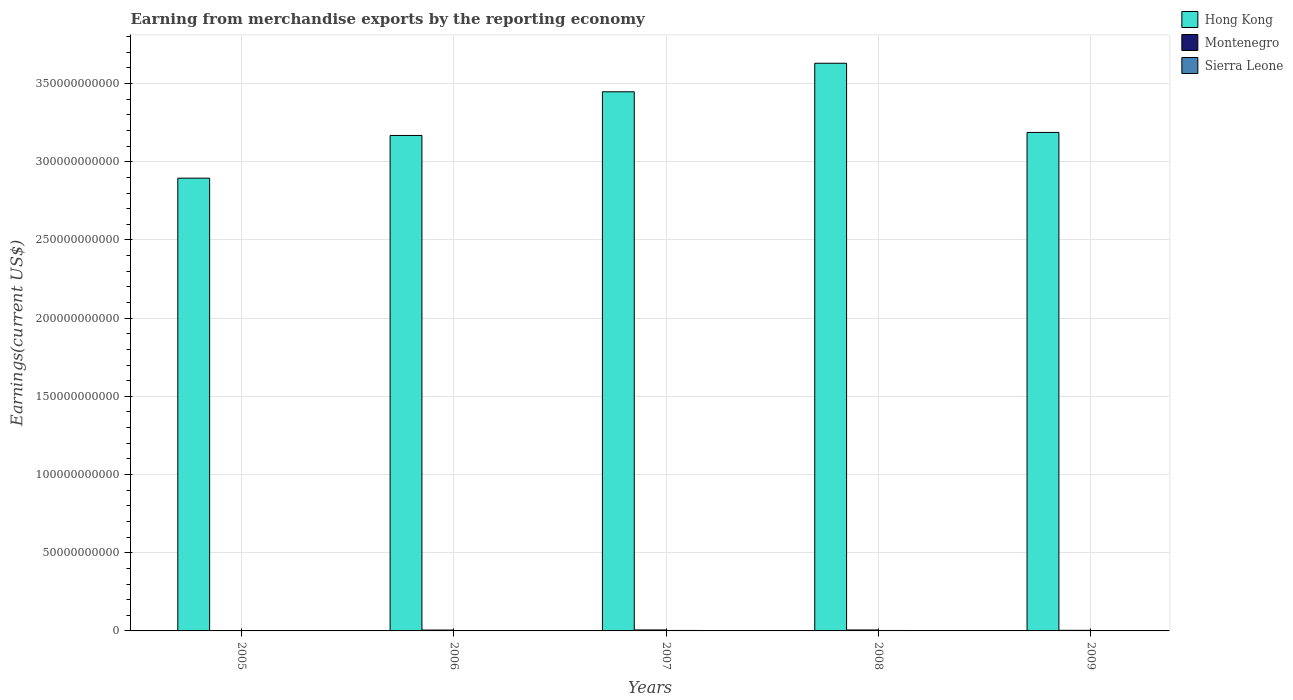Are the number of bars per tick equal to the number of legend labels?
Make the answer very short. Yes. How many bars are there on the 4th tick from the right?
Your response must be concise. 3. What is the label of the 5th group of bars from the left?
Your response must be concise. 2009. In how many cases, is the number of bars for a given year not equal to the number of legend labels?
Provide a succinct answer. 0. What is the amount earned from merchandise exports in Sierra Leone in 2009?
Keep it short and to the point. 2.15e+08. Across all years, what is the maximum amount earned from merchandise exports in Sierra Leone?
Keep it short and to the point. 3.05e+08. Across all years, what is the minimum amount earned from merchandise exports in Hong Kong?
Your answer should be very brief. 2.90e+11. In which year was the amount earned from merchandise exports in Sierra Leone minimum?
Your answer should be very brief. 2005. What is the total amount earned from merchandise exports in Sierra Leone in the graph?
Offer a very short reply. 1.20e+09. What is the difference between the amount earned from merchandise exports in Montenegro in 2008 and that in 2009?
Offer a very short reply. 2.23e+08. What is the difference between the amount earned from merchandise exports in Montenegro in 2007 and the amount earned from merchandise exports in Sierra Leone in 2009?
Provide a short and direct response. 4.06e+08. What is the average amount earned from merchandise exports in Hong Kong per year?
Ensure brevity in your answer.  3.27e+11. In the year 2005, what is the difference between the amount earned from merchandise exports in Sierra Leone and amount earned from merchandise exports in Montenegro?
Your answer should be compact. 1.04e+08. In how many years, is the amount earned from merchandise exports in Montenegro greater than 130000000000 US$?
Offer a very short reply. 0. What is the ratio of the amount earned from merchandise exports in Montenegro in 2006 to that in 2007?
Provide a succinct answer. 0.89. What is the difference between the highest and the second highest amount earned from merchandise exports in Montenegro?
Provide a succinct answer. 1.34e+07. What is the difference between the highest and the lowest amount earned from merchandise exports in Sierra Leone?
Ensure brevity in your answer.  1.09e+08. In how many years, is the amount earned from merchandise exports in Sierra Leone greater than the average amount earned from merchandise exports in Sierra Leone taken over all years?
Your response must be concise. 2. What does the 2nd bar from the left in 2005 represents?
Ensure brevity in your answer.  Montenegro. What does the 2nd bar from the right in 2008 represents?
Offer a very short reply. Montenegro. How many bars are there?
Make the answer very short. 15. Are the values on the major ticks of Y-axis written in scientific E-notation?
Provide a succinct answer. No. Where does the legend appear in the graph?
Ensure brevity in your answer.  Top right. How many legend labels are there?
Your response must be concise. 3. How are the legend labels stacked?
Offer a terse response. Vertical. What is the title of the graph?
Give a very brief answer. Earning from merchandise exports by the reporting economy. Does "Tunisia" appear as one of the legend labels in the graph?
Make the answer very short. No. What is the label or title of the X-axis?
Give a very brief answer. Years. What is the label or title of the Y-axis?
Offer a very short reply. Earnings(current US$). What is the Earnings(current US$) of Hong Kong in 2005?
Provide a succinct answer. 2.90e+11. What is the Earnings(current US$) in Montenegro in 2005?
Keep it short and to the point. 9.18e+07. What is the Earnings(current US$) in Sierra Leone in 2005?
Your answer should be compact. 1.96e+08. What is the Earnings(current US$) of Hong Kong in 2006?
Provide a succinct answer. 3.17e+11. What is the Earnings(current US$) of Montenegro in 2006?
Offer a very short reply. 5.53e+08. What is the Earnings(current US$) in Sierra Leone in 2006?
Your answer should be very brief. 2.08e+08. What is the Earnings(current US$) of Hong Kong in 2007?
Give a very brief answer. 3.45e+11. What is the Earnings(current US$) of Montenegro in 2007?
Your answer should be very brief. 6.20e+08. What is the Earnings(current US$) of Sierra Leone in 2007?
Make the answer very short. 3.05e+08. What is the Earnings(current US$) of Hong Kong in 2008?
Your answer should be compact. 3.63e+11. What is the Earnings(current US$) of Montenegro in 2008?
Make the answer very short. 6.07e+08. What is the Earnings(current US$) of Sierra Leone in 2008?
Your response must be concise. 2.73e+08. What is the Earnings(current US$) of Hong Kong in 2009?
Give a very brief answer. 3.19e+11. What is the Earnings(current US$) in Montenegro in 2009?
Make the answer very short. 3.84e+08. What is the Earnings(current US$) in Sierra Leone in 2009?
Offer a terse response. 2.15e+08. Across all years, what is the maximum Earnings(current US$) of Hong Kong?
Give a very brief answer. 3.63e+11. Across all years, what is the maximum Earnings(current US$) in Montenegro?
Keep it short and to the point. 6.20e+08. Across all years, what is the maximum Earnings(current US$) of Sierra Leone?
Your answer should be compact. 3.05e+08. Across all years, what is the minimum Earnings(current US$) in Hong Kong?
Your answer should be compact. 2.90e+11. Across all years, what is the minimum Earnings(current US$) of Montenegro?
Offer a very short reply. 9.18e+07. Across all years, what is the minimum Earnings(current US$) of Sierra Leone?
Your answer should be very brief. 1.96e+08. What is the total Earnings(current US$) of Hong Kong in the graph?
Give a very brief answer. 1.63e+12. What is the total Earnings(current US$) in Montenegro in the graph?
Provide a short and direct response. 2.26e+09. What is the total Earnings(current US$) in Sierra Leone in the graph?
Ensure brevity in your answer.  1.20e+09. What is the difference between the Earnings(current US$) of Hong Kong in 2005 and that in 2006?
Your answer should be very brief. -2.73e+1. What is the difference between the Earnings(current US$) of Montenegro in 2005 and that in 2006?
Your answer should be very brief. -4.62e+08. What is the difference between the Earnings(current US$) in Sierra Leone in 2005 and that in 2006?
Your response must be concise. -1.21e+07. What is the difference between the Earnings(current US$) in Hong Kong in 2005 and that in 2007?
Provide a succinct answer. -5.52e+1. What is the difference between the Earnings(current US$) in Montenegro in 2005 and that in 2007?
Provide a succinct answer. -5.29e+08. What is the difference between the Earnings(current US$) in Sierra Leone in 2005 and that in 2007?
Give a very brief answer. -1.09e+08. What is the difference between the Earnings(current US$) of Hong Kong in 2005 and that in 2008?
Ensure brevity in your answer.  -7.35e+1. What is the difference between the Earnings(current US$) in Montenegro in 2005 and that in 2008?
Provide a succinct answer. -5.15e+08. What is the difference between the Earnings(current US$) in Sierra Leone in 2005 and that in 2008?
Offer a very short reply. -7.68e+07. What is the difference between the Earnings(current US$) in Hong Kong in 2005 and that in 2009?
Offer a very short reply. -2.92e+1. What is the difference between the Earnings(current US$) in Montenegro in 2005 and that in 2009?
Offer a very short reply. -2.92e+08. What is the difference between the Earnings(current US$) of Sierra Leone in 2005 and that in 2009?
Your response must be concise. -1.86e+07. What is the difference between the Earnings(current US$) in Hong Kong in 2006 and that in 2007?
Ensure brevity in your answer.  -2.79e+1. What is the difference between the Earnings(current US$) in Montenegro in 2006 and that in 2007?
Your response must be concise. -6.70e+07. What is the difference between the Earnings(current US$) in Sierra Leone in 2006 and that in 2007?
Provide a short and direct response. -9.68e+07. What is the difference between the Earnings(current US$) of Hong Kong in 2006 and that in 2008?
Provide a succinct answer. -4.62e+1. What is the difference between the Earnings(current US$) in Montenegro in 2006 and that in 2008?
Ensure brevity in your answer.  -5.36e+07. What is the difference between the Earnings(current US$) in Sierra Leone in 2006 and that in 2008?
Provide a short and direct response. -6.46e+07. What is the difference between the Earnings(current US$) in Hong Kong in 2006 and that in 2009?
Provide a succinct answer. -1.93e+09. What is the difference between the Earnings(current US$) in Montenegro in 2006 and that in 2009?
Ensure brevity in your answer.  1.69e+08. What is the difference between the Earnings(current US$) of Sierra Leone in 2006 and that in 2009?
Offer a terse response. -6.45e+06. What is the difference between the Earnings(current US$) in Hong Kong in 2007 and that in 2008?
Provide a short and direct response. -1.82e+1. What is the difference between the Earnings(current US$) of Montenegro in 2007 and that in 2008?
Make the answer very short. 1.34e+07. What is the difference between the Earnings(current US$) in Sierra Leone in 2007 and that in 2008?
Offer a very short reply. 3.22e+07. What is the difference between the Earnings(current US$) of Hong Kong in 2007 and that in 2009?
Keep it short and to the point. 2.60e+1. What is the difference between the Earnings(current US$) in Montenegro in 2007 and that in 2009?
Provide a succinct answer. 2.36e+08. What is the difference between the Earnings(current US$) in Sierra Leone in 2007 and that in 2009?
Offer a very short reply. 9.04e+07. What is the difference between the Earnings(current US$) in Hong Kong in 2008 and that in 2009?
Give a very brief answer. 4.42e+1. What is the difference between the Earnings(current US$) in Montenegro in 2008 and that in 2009?
Provide a succinct answer. 2.23e+08. What is the difference between the Earnings(current US$) of Sierra Leone in 2008 and that in 2009?
Ensure brevity in your answer.  5.82e+07. What is the difference between the Earnings(current US$) in Hong Kong in 2005 and the Earnings(current US$) in Montenegro in 2006?
Offer a terse response. 2.89e+11. What is the difference between the Earnings(current US$) in Hong Kong in 2005 and the Earnings(current US$) in Sierra Leone in 2006?
Your response must be concise. 2.89e+11. What is the difference between the Earnings(current US$) in Montenegro in 2005 and the Earnings(current US$) in Sierra Leone in 2006?
Your answer should be compact. -1.16e+08. What is the difference between the Earnings(current US$) of Hong Kong in 2005 and the Earnings(current US$) of Montenegro in 2007?
Provide a succinct answer. 2.89e+11. What is the difference between the Earnings(current US$) of Hong Kong in 2005 and the Earnings(current US$) of Sierra Leone in 2007?
Your answer should be compact. 2.89e+11. What is the difference between the Earnings(current US$) in Montenegro in 2005 and the Earnings(current US$) in Sierra Leone in 2007?
Your answer should be very brief. -2.13e+08. What is the difference between the Earnings(current US$) in Hong Kong in 2005 and the Earnings(current US$) in Montenegro in 2008?
Your answer should be very brief. 2.89e+11. What is the difference between the Earnings(current US$) of Hong Kong in 2005 and the Earnings(current US$) of Sierra Leone in 2008?
Your answer should be very brief. 2.89e+11. What is the difference between the Earnings(current US$) of Montenegro in 2005 and the Earnings(current US$) of Sierra Leone in 2008?
Your response must be concise. -1.81e+08. What is the difference between the Earnings(current US$) in Hong Kong in 2005 and the Earnings(current US$) in Montenegro in 2009?
Provide a succinct answer. 2.89e+11. What is the difference between the Earnings(current US$) of Hong Kong in 2005 and the Earnings(current US$) of Sierra Leone in 2009?
Provide a short and direct response. 2.89e+11. What is the difference between the Earnings(current US$) in Montenegro in 2005 and the Earnings(current US$) in Sierra Leone in 2009?
Ensure brevity in your answer.  -1.23e+08. What is the difference between the Earnings(current US$) of Hong Kong in 2006 and the Earnings(current US$) of Montenegro in 2007?
Provide a succinct answer. 3.16e+11. What is the difference between the Earnings(current US$) of Hong Kong in 2006 and the Earnings(current US$) of Sierra Leone in 2007?
Give a very brief answer. 3.17e+11. What is the difference between the Earnings(current US$) of Montenegro in 2006 and the Earnings(current US$) of Sierra Leone in 2007?
Make the answer very short. 2.48e+08. What is the difference between the Earnings(current US$) in Hong Kong in 2006 and the Earnings(current US$) in Montenegro in 2008?
Your response must be concise. 3.16e+11. What is the difference between the Earnings(current US$) in Hong Kong in 2006 and the Earnings(current US$) in Sierra Leone in 2008?
Provide a succinct answer. 3.17e+11. What is the difference between the Earnings(current US$) of Montenegro in 2006 and the Earnings(current US$) of Sierra Leone in 2008?
Offer a very short reply. 2.81e+08. What is the difference between the Earnings(current US$) of Hong Kong in 2006 and the Earnings(current US$) of Montenegro in 2009?
Give a very brief answer. 3.16e+11. What is the difference between the Earnings(current US$) of Hong Kong in 2006 and the Earnings(current US$) of Sierra Leone in 2009?
Provide a succinct answer. 3.17e+11. What is the difference between the Earnings(current US$) of Montenegro in 2006 and the Earnings(current US$) of Sierra Leone in 2009?
Your answer should be very brief. 3.39e+08. What is the difference between the Earnings(current US$) of Hong Kong in 2007 and the Earnings(current US$) of Montenegro in 2008?
Make the answer very short. 3.44e+11. What is the difference between the Earnings(current US$) in Hong Kong in 2007 and the Earnings(current US$) in Sierra Leone in 2008?
Your answer should be compact. 3.44e+11. What is the difference between the Earnings(current US$) in Montenegro in 2007 and the Earnings(current US$) in Sierra Leone in 2008?
Offer a very short reply. 3.48e+08. What is the difference between the Earnings(current US$) in Hong Kong in 2007 and the Earnings(current US$) in Montenegro in 2009?
Make the answer very short. 3.44e+11. What is the difference between the Earnings(current US$) in Hong Kong in 2007 and the Earnings(current US$) in Sierra Leone in 2009?
Your response must be concise. 3.45e+11. What is the difference between the Earnings(current US$) in Montenegro in 2007 and the Earnings(current US$) in Sierra Leone in 2009?
Ensure brevity in your answer.  4.06e+08. What is the difference between the Earnings(current US$) in Hong Kong in 2008 and the Earnings(current US$) in Montenegro in 2009?
Offer a very short reply. 3.63e+11. What is the difference between the Earnings(current US$) in Hong Kong in 2008 and the Earnings(current US$) in Sierra Leone in 2009?
Your answer should be compact. 3.63e+11. What is the difference between the Earnings(current US$) in Montenegro in 2008 and the Earnings(current US$) in Sierra Leone in 2009?
Ensure brevity in your answer.  3.92e+08. What is the average Earnings(current US$) in Hong Kong per year?
Offer a very short reply. 3.27e+11. What is the average Earnings(current US$) of Montenegro per year?
Provide a succinct answer. 4.51e+08. What is the average Earnings(current US$) in Sierra Leone per year?
Give a very brief answer. 2.39e+08. In the year 2005, what is the difference between the Earnings(current US$) of Hong Kong and Earnings(current US$) of Montenegro?
Give a very brief answer. 2.89e+11. In the year 2005, what is the difference between the Earnings(current US$) of Hong Kong and Earnings(current US$) of Sierra Leone?
Offer a terse response. 2.89e+11. In the year 2005, what is the difference between the Earnings(current US$) in Montenegro and Earnings(current US$) in Sierra Leone?
Ensure brevity in your answer.  -1.04e+08. In the year 2006, what is the difference between the Earnings(current US$) of Hong Kong and Earnings(current US$) of Montenegro?
Your answer should be very brief. 3.16e+11. In the year 2006, what is the difference between the Earnings(current US$) in Hong Kong and Earnings(current US$) in Sierra Leone?
Provide a short and direct response. 3.17e+11. In the year 2006, what is the difference between the Earnings(current US$) in Montenegro and Earnings(current US$) in Sierra Leone?
Make the answer very short. 3.45e+08. In the year 2007, what is the difference between the Earnings(current US$) of Hong Kong and Earnings(current US$) of Montenegro?
Offer a terse response. 3.44e+11. In the year 2007, what is the difference between the Earnings(current US$) of Hong Kong and Earnings(current US$) of Sierra Leone?
Provide a succinct answer. 3.44e+11. In the year 2007, what is the difference between the Earnings(current US$) in Montenegro and Earnings(current US$) in Sierra Leone?
Keep it short and to the point. 3.15e+08. In the year 2008, what is the difference between the Earnings(current US$) of Hong Kong and Earnings(current US$) of Montenegro?
Offer a very short reply. 3.62e+11. In the year 2008, what is the difference between the Earnings(current US$) in Hong Kong and Earnings(current US$) in Sierra Leone?
Provide a short and direct response. 3.63e+11. In the year 2008, what is the difference between the Earnings(current US$) of Montenegro and Earnings(current US$) of Sierra Leone?
Your response must be concise. 3.34e+08. In the year 2009, what is the difference between the Earnings(current US$) in Hong Kong and Earnings(current US$) in Montenegro?
Offer a very short reply. 3.18e+11. In the year 2009, what is the difference between the Earnings(current US$) in Hong Kong and Earnings(current US$) in Sierra Leone?
Provide a short and direct response. 3.19e+11. In the year 2009, what is the difference between the Earnings(current US$) of Montenegro and Earnings(current US$) of Sierra Leone?
Give a very brief answer. 1.69e+08. What is the ratio of the Earnings(current US$) of Hong Kong in 2005 to that in 2006?
Your answer should be compact. 0.91. What is the ratio of the Earnings(current US$) of Montenegro in 2005 to that in 2006?
Provide a short and direct response. 0.17. What is the ratio of the Earnings(current US$) in Sierra Leone in 2005 to that in 2006?
Make the answer very short. 0.94. What is the ratio of the Earnings(current US$) in Hong Kong in 2005 to that in 2007?
Keep it short and to the point. 0.84. What is the ratio of the Earnings(current US$) in Montenegro in 2005 to that in 2007?
Make the answer very short. 0.15. What is the ratio of the Earnings(current US$) of Sierra Leone in 2005 to that in 2007?
Your response must be concise. 0.64. What is the ratio of the Earnings(current US$) of Hong Kong in 2005 to that in 2008?
Offer a terse response. 0.8. What is the ratio of the Earnings(current US$) in Montenegro in 2005 to that in 2008?
Your answer should be compact. 0.15. What is the ratio of the Earnings(current US$) in Sierra Leone in 2005 to that in 2008?
Ensure brevity in your answer.  0.72. What is the ratio of the Earnings(current US$) in Hong Kong in 2005 to that in 2009?
Provide a succinct answer. 0.91. What is the ratio of the Earnings(current US$) of Montenegro in 2005 to that in 2009?
Your answer should be very brief. 0.24. What is the ratio of the Earnings(current US$) of Sierra Leone in 2005 to that in 2009?
Keep it short and to the point. 0.91. What is the ratio of the Earnings(current US$) of Hong Kong in 2006 to that in 2007?
Your response must be concise. 0.92. What is the ratio of the Earnings(current US$) of Montenegro in 2006 to that in 2007?
Your answer should be compact. 0.89. What is the ratio of the Earnings(current US$) in Sierra Leone in 2006 to that in 2007?
Offer a terse response. 0.68. What is the ratio of the Earnings(current US$) of Hong Kong in 2006 to that in 2008?
Offer a terse response. 0.87. What is the ratio of the Earnings(current US$) of Montenegro in 2006 to that in 2008?
Your answer should be very brief. 0.91. What is the ratio of the Earnings(current US$) in Sierra Leone in 2006 to that in 2008?
Provide a succinct answer. 0.76. What is the ratio of the Earnings(current US$) of Montenegro in 2006 to that in 2009?
Keep it short and to the point. 1.44. What is the ratio of the Earnings(current US$) of Sierra Leone in 2006 to that in 2009?
Offer a terse response. 0.97. What is the ratio of the Earnings(current US$) of Hong Kong in 2007 to that in 2008?
Offer a very short reply. 0.95. What is the ratio of the Earnings(current US$) in Montenegro in 2007 to that in 2008?
Ensure brevity in your answer.  1.02. What is the ratio of the Earnings(current US$) in Sierra Leone in 2007 to that in 2008?
Provide a short and direct response. 1.12. What is the ratio of the Earnings(current US$) of Hong Kong in 2007 to that in 2009?
Your answer should be very brief. 1.08. What is the ratio of the Earnings(current US$) of Montenegro in 2007 to that in 2009?
Your response must be concise. 1.62. What is the ratio of the Earnings(current US$) in Sierra Leone in 2007 to that in 2009?
Your answer should be very brief. 1.42. What is the ratio of the Earnings(current US$) of Hong Kong in 2008 to that in 2009?
Offer a very short reply. 1.14. What is the ratio of the Earnings(current US$) in Montenegro in 2008 to that in 2009?
Offer a very short reply. 1.58. What is the ratio of the Earnings(current US$) in Sierra Leone in 2008 to that in 2009?
Ensure brevity in your answer.  1.27. What is the difference between the highest and the second highest Earnings(current US$) in Hong Kong?
Keep it short and to the point. 1.82e+1. What is the difference between the highest and the second highest Earnings(current US$) of Montenegro?
Your answer should be compact. 1.34e+07. What is the difference between the highest and the second highest Earnings(current US$) of Sierra Leone?
Give a very brief answer. 3.22e+07. What is the difference between the highest and the lowest Earnings(current US$) of Hong Kong?
Offer a very short reply. 7.35e+1. What is the difference between the highest and the lowest Earnings(current US$) of Montenegro?
Provide a short and direct response. 5.29e+08. What is the difference between the highest and the lowest Earnings(current US$) of Sierra Leone?
Give a very brief answer. 1.09e+08. 